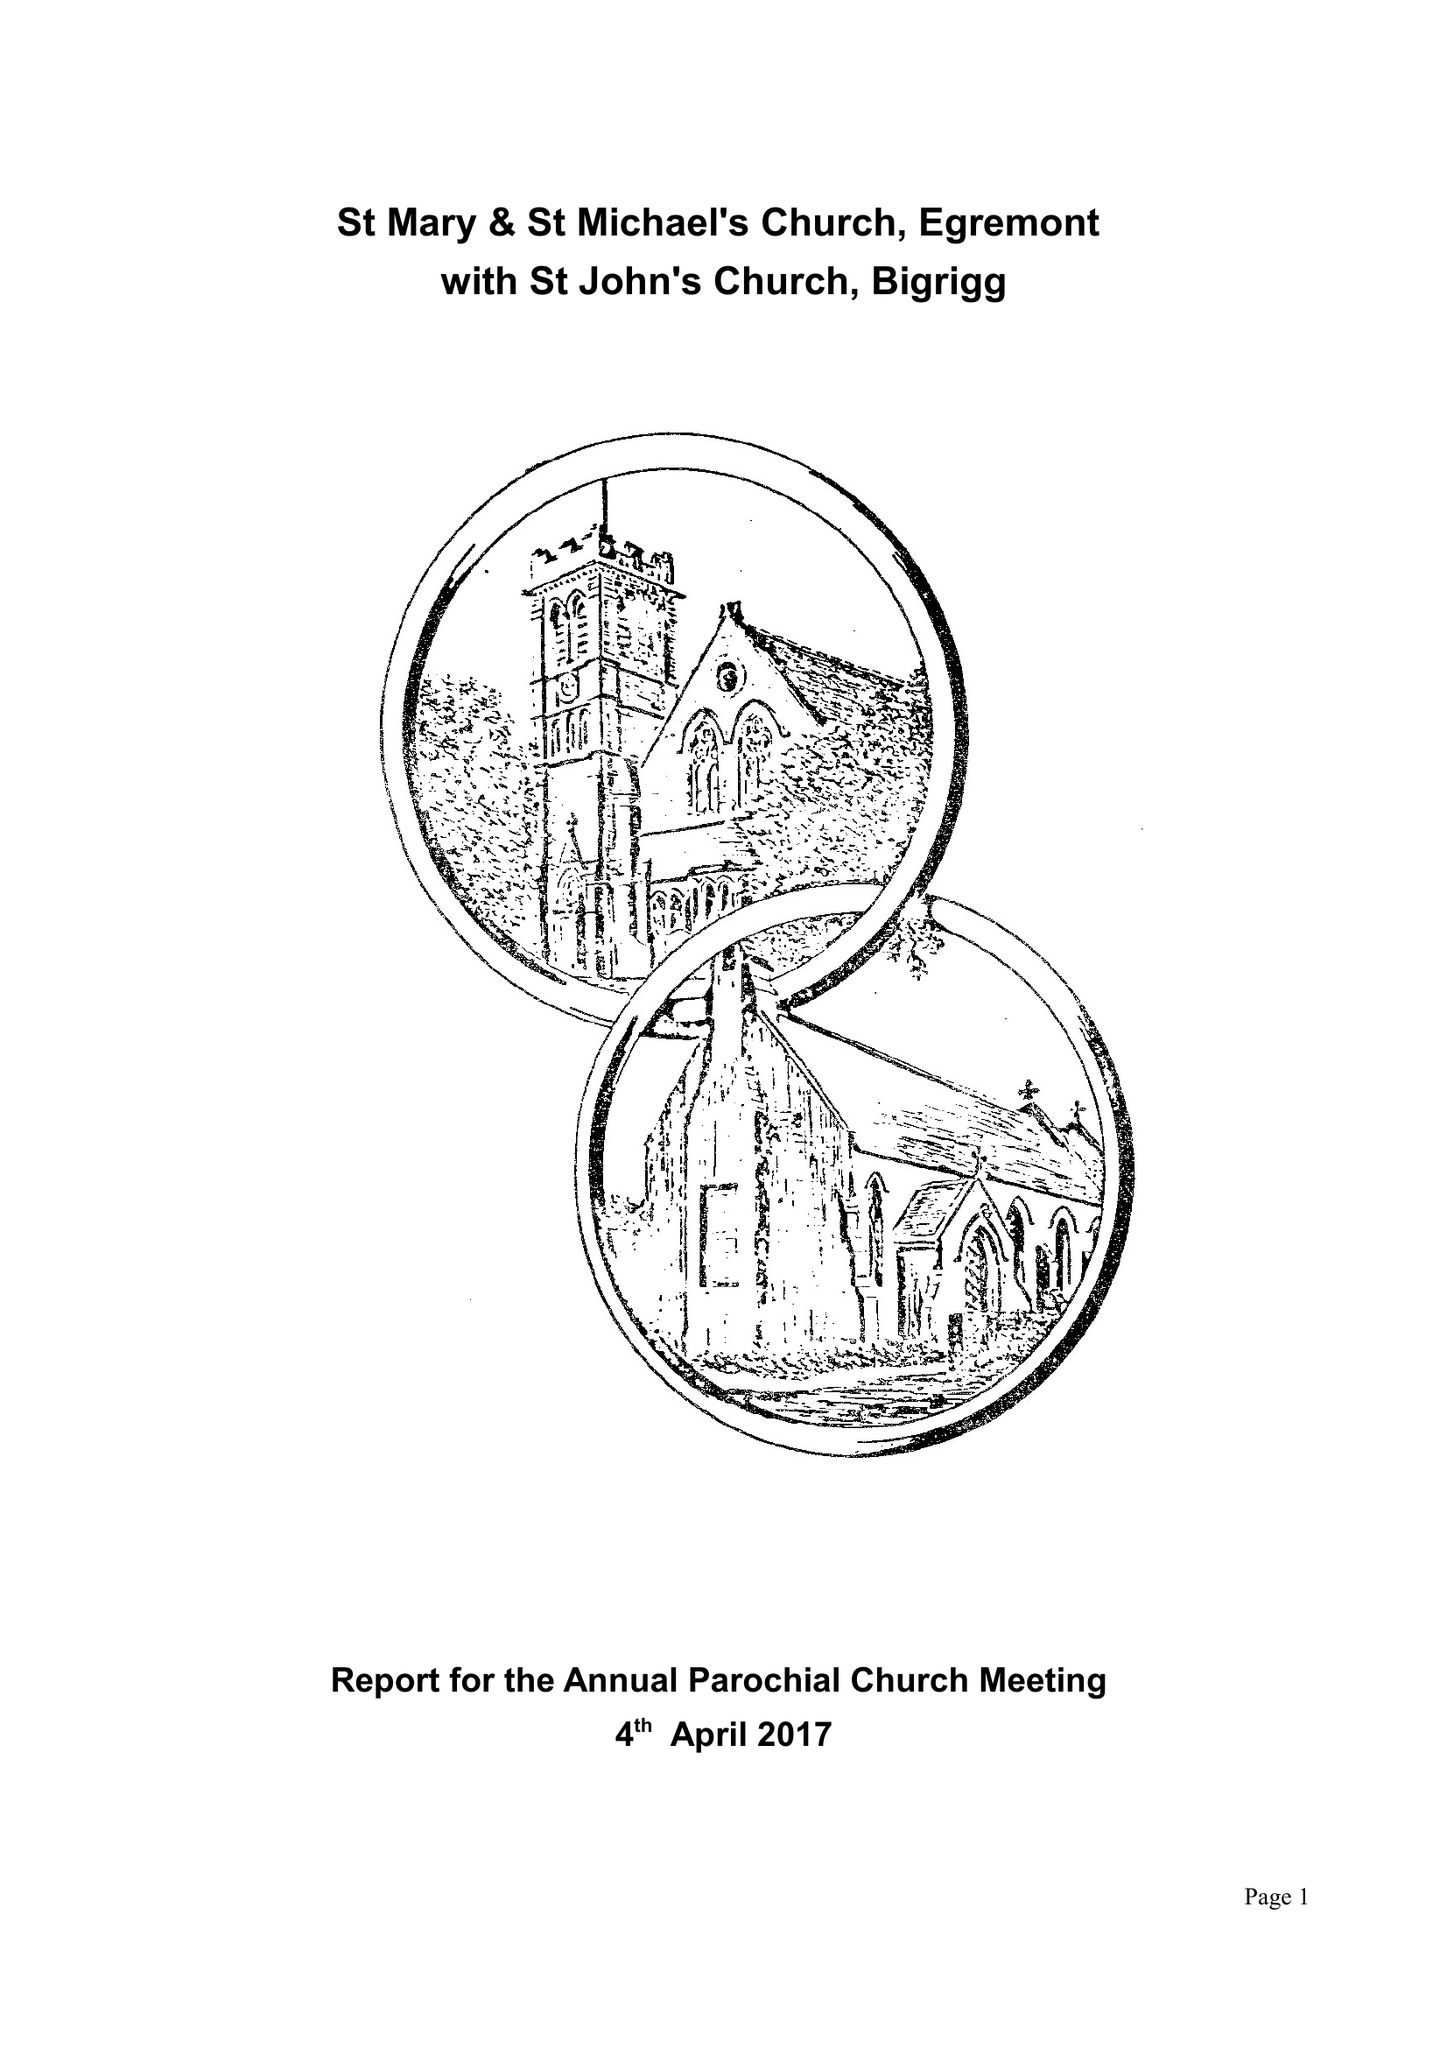What is the value for the income_annually_in_british_pounds?
Answer the question using a single word or phrase. 102917.00 